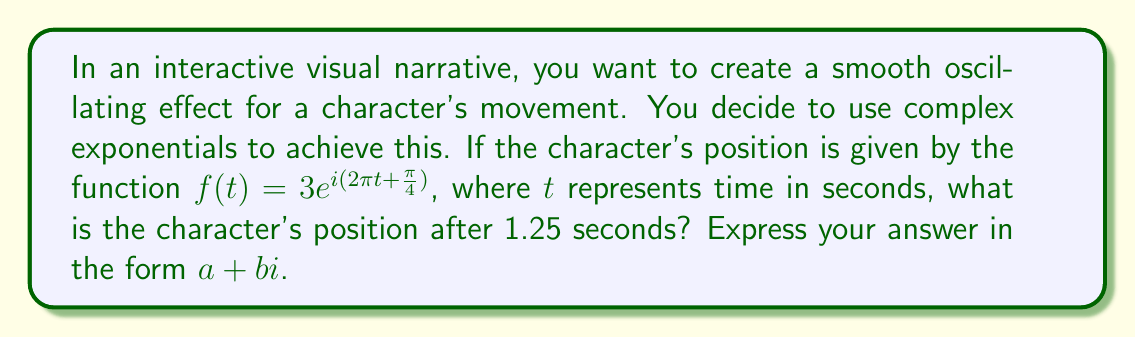Can you answer this question? Let's approach this step-by-step:

1) We're given the function $f(t) = 3e^{i(2\pi t + \frac{\pi}{4})}$

2) We need to find $f(1.25)$, so let's substitute $t = 1.25$:

   $f(1.25) = 3e^{i(2\pi(1.25) + \frac{\pi}{4})}$

3) Simplify the exponent:
   
   $f(1.25) = 3e^{i(2.5\pi + \frac{\pi}{4})} = 3e^{i(2.75\pi)}$

4) Now, we can use Euler's formula: $e^{i\theta} = \cos\theta + i\sin\theta$

   $f(1.25) = 3(\cos(2.75\pi) + i\sin(2.75\pi))$

5) Evaluate $2.75\pi$:
   
   $2.75\pi = 2\pi + 0.75\pi = 2\pi + \frac{3\pi}{4}$

6) We know that $\cos(2\pi + \theta) = \cos\theta$ and $\sin(2\pi + \theta) = \sin\theta$, so:

   $f(1.25) = 3(\cos(\frac{3\pi}{4}) + i\sin(\frac{3\pi}{4}))$

7) Evaluate $\cos(\frac{3\pi}{4})$ and $\sin(\frac{3\pi}{4})$:

   $\cos(\frac{3\pi}{4}) = -\frac{\sqrt{2}}{2}$
   $\sin(\frac{3\pi}{4}) = \frac{\sqrt{2}}{2}$

8) Substitute these values:

   $f(1.25) = 3(-\frac{\sqrt{2}}{2} + i\frac{\sqrt{2}}{2})$

9) Simplify:

   $f(1.25) = -\frac{3\sqrt{2}}{2} + i\frac{3\sqrt{2}}{2}$

This is our final answer in the form $a + bi$.
Answer: $-\frac{3\sqrt{2}}{2} + i\frac{3\sqrt{2}}{2}$ 